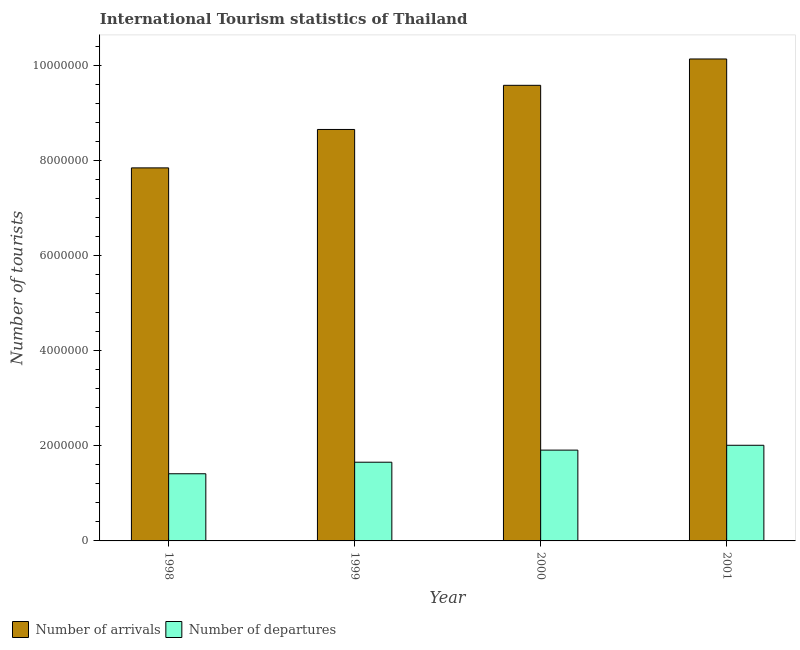How many different coloured bars are there?
Offer a very short reply. 2. In how many cases, is the number of bars for a given year not equal to the number of legend labels?
Provide a short and direct response. 0. What is the number of tourist departures in 1999?
Your answer should be compact. 1.66e+06. Across all years, what is the maximum number of tourist arrivals?
Keep it short and to the point. 1.01e+07. Across all years, what is the minimum number of tourist departures?
Provide a succinct answer. 1.41e+06. In which year was the number of tourist departures maximum?
Your answer should be very brief. 2001. What is the total number of tourist arrivals in the graph?
Make the answer very short. 3.62e+07. What is the difference between the number of tourist departures in 1999 and that in 2001?
Offer a terse response. -3.56e+05. What is the difference between the number of tourist arrivals in 2000 and the number of tourist departures in 1998?
Keep it short and to the point. 1.74e+06. What is the average number of tourist arrivals per year?
Offer a very short reply. 9.05e+06. What is the ratio of the number of tourist arrivals in 1998 to that in 2001?
Provide a succinct answer. 0.77. Is the number of tourist departures in 1999 less than that in 2001?
Provide a short and direct response. Yes. Is the difference between the number of tourist departures in 1999 and 2001 greater than the difference between the number of tourist arrivals in 1999 and 2001?
Offer a terse response. No. What is the difference between the highest and the second highest number of tourist departures?
Your answer should be very brief. 1.02e+05. What is the difference between the highest and the lowest number of tourist arrivals?
Provide a short and direct response. 2.29e+06. Is the sum of the number of tourist arrivals in 1998 and 2001 greater than the maximum number of tourist departures across all years?
Offer a terse response. Yes. What does the 1st bar from the left in 2000 represents?
Offer a terse response. Number of arrivals. What does the 2nd bar from the right in 2001 represents?
Your answer should be very brief. Number of arrivals. How many bars are there?
Provide a short and direct response. 8. How many years are there in the graph?
Ensure brevity in your answer.  4. Does the graph contain any zero values?
Your response must be concise. No. How are the legend labels stacked?
Make the answer very short. Horizontal. What is the title of the graph?
Give a very brief answer. International Tourism statistics of Thailand. Does "Private credit bureau" appear as one of the legend labels in the graph?
Provide a succinct answer. No. What is the label or title of the Y-axis?
Your answer should be compact. Number of tourists. What is the Number of tourists in Number of arrivals in 1998?
Keep it short and to the point. 7.84e+06. What is the Number of tourists of Number of departures in 1998?
Your answer should be very brief. 1.41e+06. What is the Number of tourists of Number of arrivals in 1999?
Make the answer very short. 8.65e+06. What is the Number of tourists of Number of departures in 1999?
Give a very brief answer. 1.66e+06. What is the Number of tourists in Number of arrivals in 2000?
Keep it short and to the point. 9.58e+06. What is the Number of tourists in Number of departures in 2000?
Keep it short and to the point. 1.91e+06. What is the Number of tourists of Number of arrivals in 2001?
Your answer should be compact. 1.01e+07. What is the Number of tourists in Number of departures in 2001?
Keep it short and to the point. 2.01e+06. Across all years, what is the maximum Number of tourists of Number of arrivals?
Keep it short and to the point. 1.01e+07. Across all years, what is the maximum Number of tourists in Number of departures?
Keep it short and to the point. 2.01e+06. Across all years, what is the minimum Number of tourists of Number of arrivals?
Your answer should be compact. 7.84e+06. Across all years, what is the minimum Number of tourists in Number of departures?
Offer a terse response. 1.41e+06. What is the total Number of tourists in Number of arrivals in the graph?
Make the answer very short. 3.62e+07. What is the total Number of tourists of Number of departures in the graph?
Give a very brief answer. 6.99e+06. What is the difference between the Number of tourists of Number of arrivals in 1998 and that in 1999?
Offer a terse response. -8.08e+05. What is the difference between the Number of tourists in Number of departures in 1998 and that in 1999?
Offer a terse response. -2.43e+05. What is the difference between the Number of tourists in Number of arrivals in 1998 and that in 2000?
Offer a very short reply. -1.74e+06. What is the difference between the Number of tourists in Number of departures in 1998 and that in 2000?
Provide a succinct answer. -4.97e+05. What is the difference between the Number of tourists in Number of arrivals in 1998 and that in 2001?
Provide a short and direct response. -2.29e+06. What is the difference between the Number of tourists in Number of departures in 1998 and that in 2001?
Offer a terse response. -5.99e+05. What is the difference between the Number of tourists of Number of arrivals in 1999 and that in 2000?
Keep it short and to the point. -9.28e+05. What is the difference between the Number of tourists of Number of departures in 1999 and that in 2000?
Give a very brief answer. -2.54e+05. What is the difference between the Number of tourists of Number of arrivals in 1999 and that in 2001?
Your answer should be compact. -1.48e+06. What is the difference between the Number of tourists of Number of departures in 1999 and that in 2001?
Provide a short and direct response. -3.56e+05. What is the difference between the Number of tourists of Number of arrivals in 2000 and that in 2001?
Offer a terse response. -5.54e+05. What is the difference between the Number of tourists in Number of departures in 2000 and that in 2001?
Ensure brevity in your answer.  -1.02e+05. What is the difference between the Number of tourists of Number of arrivals in 1998 and the Number of tourists of Number of departures in 1999?
Your answer should be very brief. 6.19e+06. What is the difference between the Number of tourists in Number of arrivals in 1998 and the Number of tourists in Number of departures in 2000?
Provide a succinct answer. 5.93e+06. What is the difference between the Number of tourists of Number of arrivals in 1998 and the Number of tourists of Number of departures in 2001?
Provide a succinct answer. 5.83e+06. What is the difference between the Number of tourists in Number of arrivals in 1999 and the Number of tourists in Number of departures in 2000?
Your answer should be compact. 6.74e+06. What is the difference between the Number of tourists of Number of arrivals in 1999 and the Number of tourists of Number of departures in 2001?
Give a very brief answer. 6.64e+06. What is the difference between the Number of tourists of Number of arrivals in 2000 and the Number of tourists of Number of departures in 2001?
Provide a short and direct response. 7.57e+06. What is the average Number of tourists in Number of arrivals per year?
Your answer should be very brief. 9.05e+06. What is the average Number of tourists of Number of departures per year?
Keep it short and to the point. 1.75e+06. In the year 1998, what is the difference between the Number of tourists in Number of arrivals and Number of tourists in Number of departures?
Give a very brief answer. 6.43e+06. In the year 1999, what is the difference between the Number of tourists in Number of arrivals and Number of tourists in Number of departures?
Give a very brief answer. 7.00e+06. In the year 2000, what is the difference between the Number of tourists of Number of arrivals and Number of tourists of Number of departures?
Make the answer very short. 7.67e+06. In the year 2001, what is the difference between the Number of tourists in Number of arrivals and Number of tourists in Number of departures?
Give a very brief answer. 8.12e+06. What is the ratio of the Number of tourists of Number of arrivals in 1998 to that in 1999?
Keep it short and to the point. 0.91. What is the ratio of the Number of tourists of Number of departures in 1998 to that in 1999?
Provide a short and direct response. 0.85. What is the ratio of the Number of tourists of Number of arrivals in 1998 to that in 2000?
Your response must be concise. 0.82. What is the ratio of the Number of tourists in Number of departures in 1998 to that in 2000?
Provide a succinct answer. 0.74. What is the ratio of the Number of tourists in Number of arrivals in 1998 to that in 2001?
Your response must be concise. 0.77. What is the ratio of the Number of tourists in Number of departures in 1998 to that in 2001?
Offer a very short reply. 0.7. What is the ratio of the Number of tourists in Number of arrivals in 1999 to that in 2000?
Keep it short and to the point. 0.9. What is the ratio of the Number of tourists in Number of departures in 1999 to that in 2000?
Keep it short and to the point. 0.87. What is the ratio of the Number of tourists of Number of arrivals in 1999 to that in 2001?
Your answer should be very brief. 0.85. What is the ratio of the Number of tourists of Number of departures in 1999 to that in 2001?
Offer a terse response. 0.82. What is the ratio of the Number of tourists of Number of arrivals in 2000 to that in 2001?
Keep it short and to the point. 0.95. What is the ratio of the Number of tourists of Number of departures in 2000 to that in 2001?
Give a very brief answer. 0.95. What is the difference between the highest and the second highest Number of tourists in Number of arrivals?
Provide a short and direct response. 5.54e+05. What is the difference between the highest and the second highest Number of tourists in Number of departures?
Make the answer very short. 1.02e+05. What is the difference between the highest and the lowest Number of tourists of Number of arrivals?
Provide a succinct answer. 2.29e+06. What is the difference between the highest and the lowest Number of tourists in Number of departures?
Provide a succinct answer. 5.99e+05. 